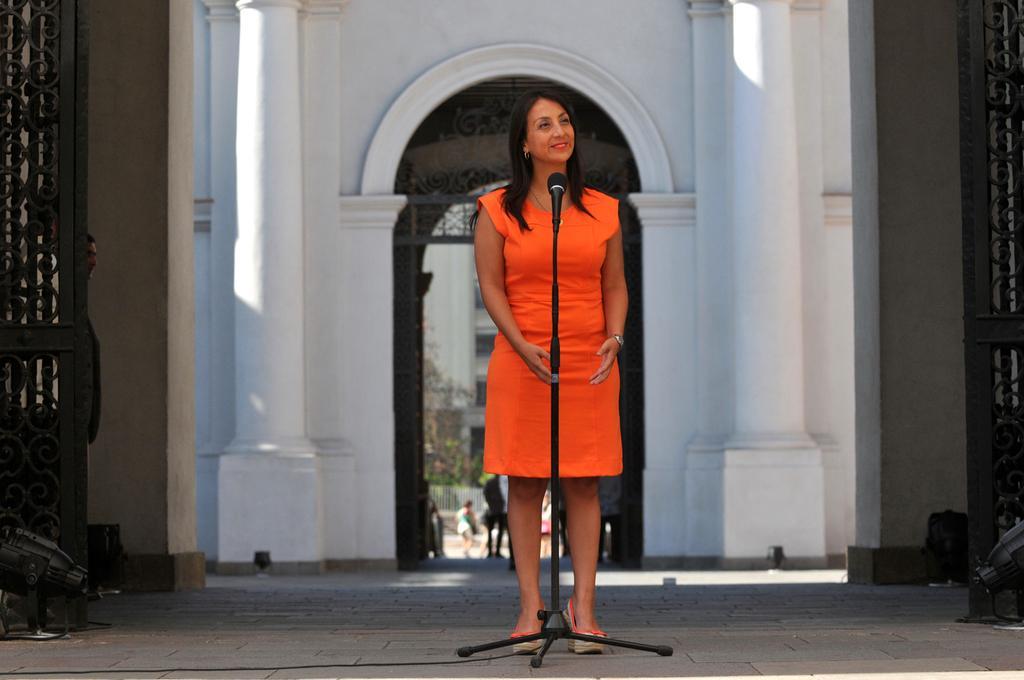How would you summarize this image in a sentence or two? In the center of the image a lady is standing and mic, stand are present. In the background of the image wall, door, lights are present. At the bottom of the image floor is there. In the center of the image we can see building, tree, grills and some persons are there. 